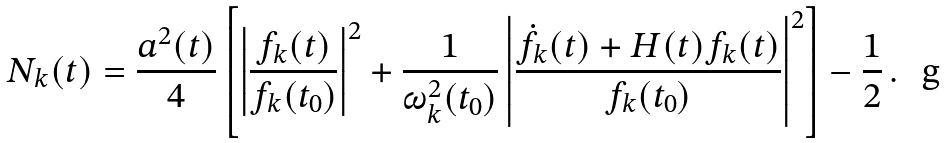<formula> <loc_0><loc_0><loc_500><loc_500>N _ { k } ( t ) = \frac { a ^ { 2 } ( t ) } { 4 } \left [ \left | \frac { f _ { k } ( t ) } { f _ { k } ( t _ { 0 } ) } \right | ^ { 2 } + \frac { 1 } { \omega ^ { 2 } _ { k } ( t _ { 0 } ) } \left | \frac { \dot { f } _ { k } ( t ) + H ( t ) f _ { k } ( t ) } { f _ { k } ( t _ { 0 } ) } \right | ^ { 2 } \right ] - \frac { 1 } { 2 } \, .</formula> 